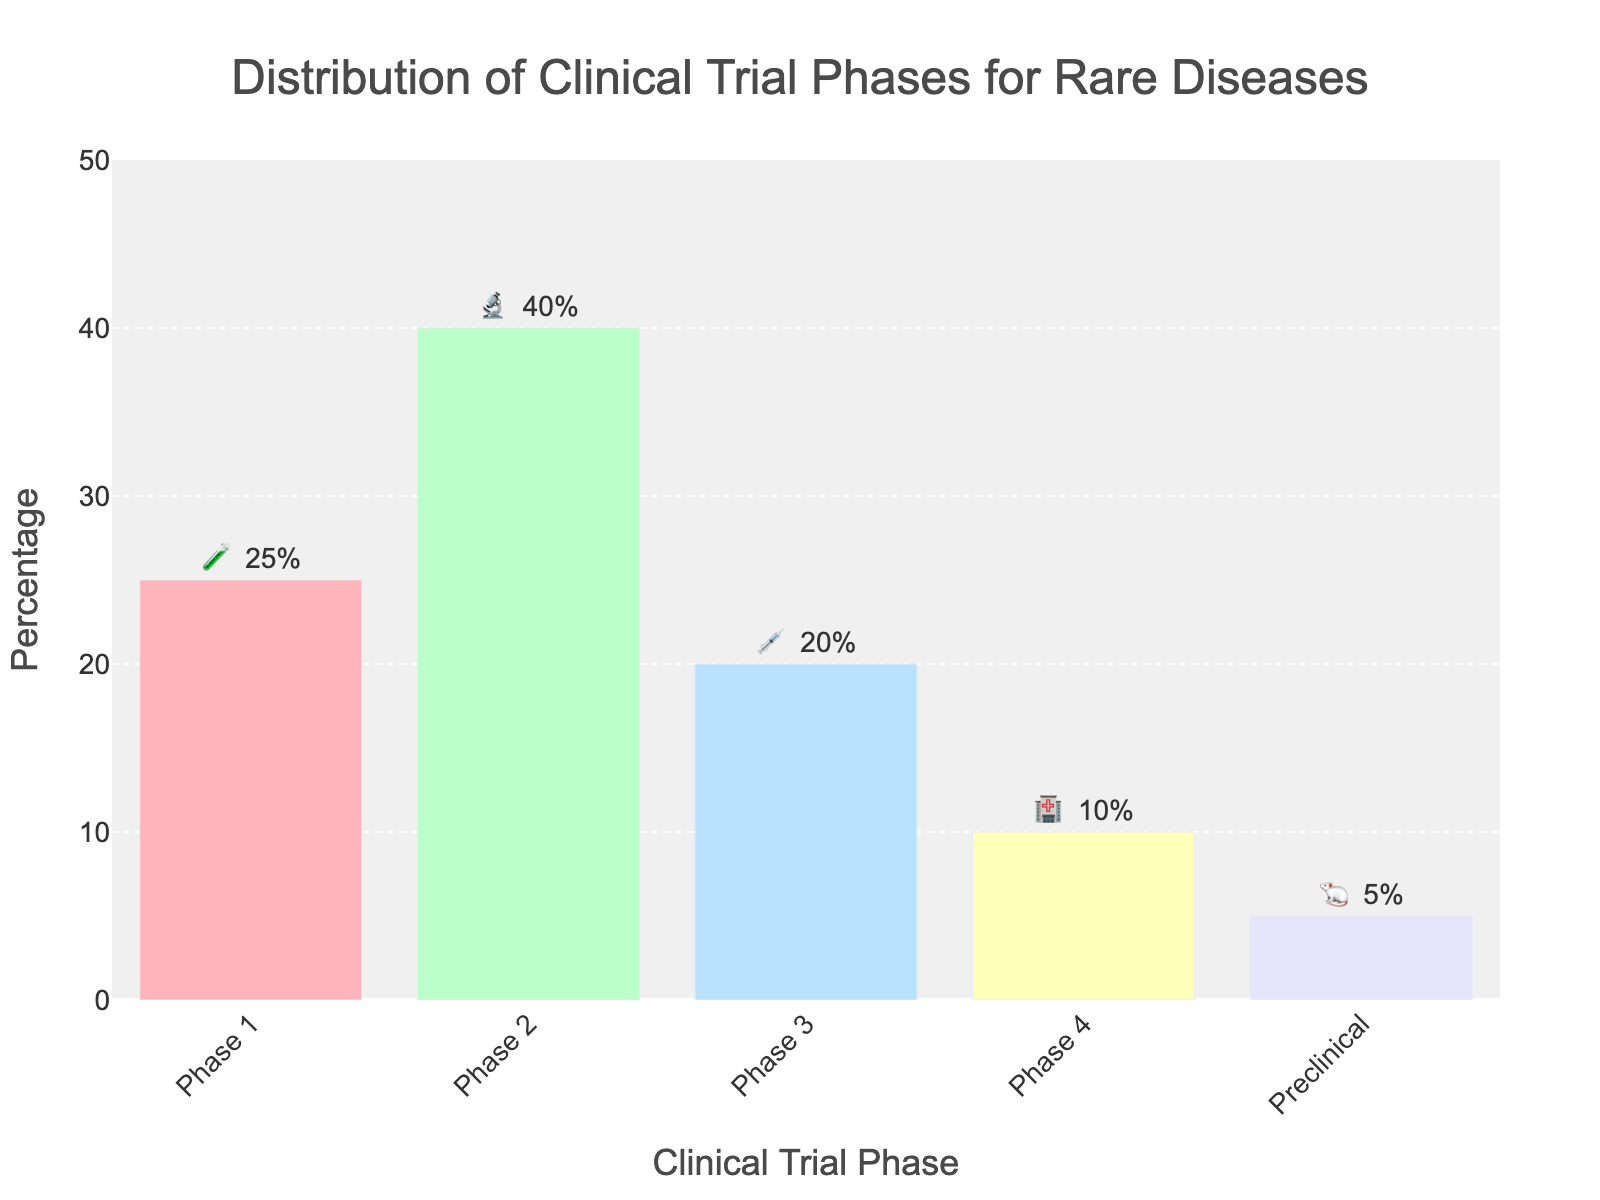What's the title of the chart? The chart's title is located at the top, centered, specifying what the data represents. It reads "Distribution of Clinical Trial Phases for Rare Diseases".
Answer: Distribution of Clinical Trial Phases for Rare Diseases Which phase has the highest percentage, and how much is it? By observing the height of the bars or the text labels, Phase 2 is identified as the tallest bar with "40%" indicated next to the 🔬 emoji.
Answer: Phase 2, 40% What is the combined percentage for Phase 1 and Phase 3? Phase 1 and Phase 3 have 25% and 20% respectively. Adding these values results in 25% + 20% = 45%.
Answer: 45% Which phase has the lowest percentage, and what is it? The smallest bar is for Preclinical with 5%, indicated next to the 🐁 emoji.
Answer: Preclinical, 5% How much greater is the percentage of Phase 2 compared to Phase 4? Extracting the percentages, Phase 2 has 40% and Phase 4 has 10%. The difference is calculated as 40% - 10% = 30%.
Answer: 30% What is the percentage represented by the 🧪 emoji? The 🧪 emoji corresponds to Phase 1, which has a percentage of 25% indicated next to it.
Answer: 25% What’s the color of the bar representing Phase 3? Phase 3, represented by a bar under the 💉 emoji, is colored in a light blue shade.
Answer: Light blue Which phases collectively represent over half of the total distribution? Phases 1 (25%) and 2 (40%) when summed give 25% + 40% = 65%, which is greater than 50%.
Answer: Phases 1 and 2 How much higher is the combined percentage of Phase 1 and Preclinical compared to Phase 4? Phase 1 (25%) and Preclinical (5%) together make 25% + 5% = 30%. Phase 4 is 10%. The difference is 30% - 10% = 20%.
Answer: 20% What symbol represents the Preclinical phase, and what is its percentage? The Preclinical phase is represented by the 🐁 emoji, and its percentage is given as 5%.
Answer: 🐁, 5% 